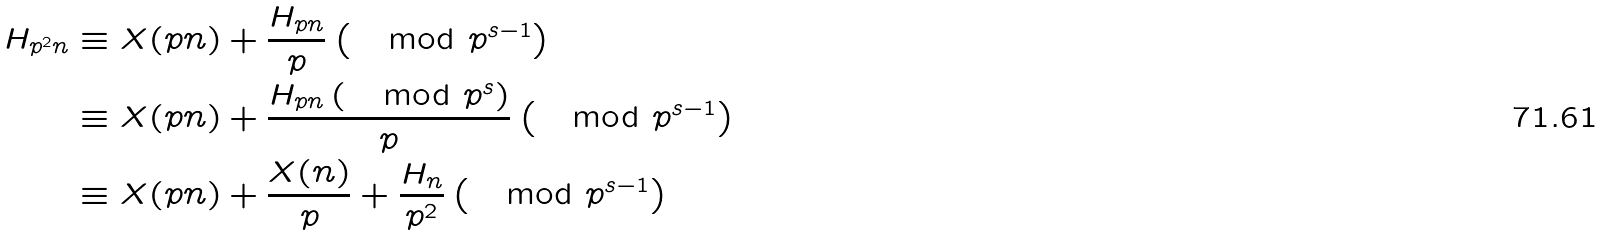<formula> <loc_0><loc_0><loc_500><loc_500>H _ { p ^ { 2 } n } & \equiv X ( p n ) + \frac { H _ { p n } } { p } \left ( \mod p ^ { s - 1 } \right ) \\ & \equiv X ( p n ) + \frac { H _ { p n } \left ( \mod p ^ { s } \right ) } { p } \left ( \mod p ^ { s - 1 } \right ) \\ & \equiv X ( p n ) + \frac { X ( n ) } { p } + \frac { H _ { n } } { p ^ { 2 } } \left ( \mod p ^ { s - 1 } \right )</formula> 